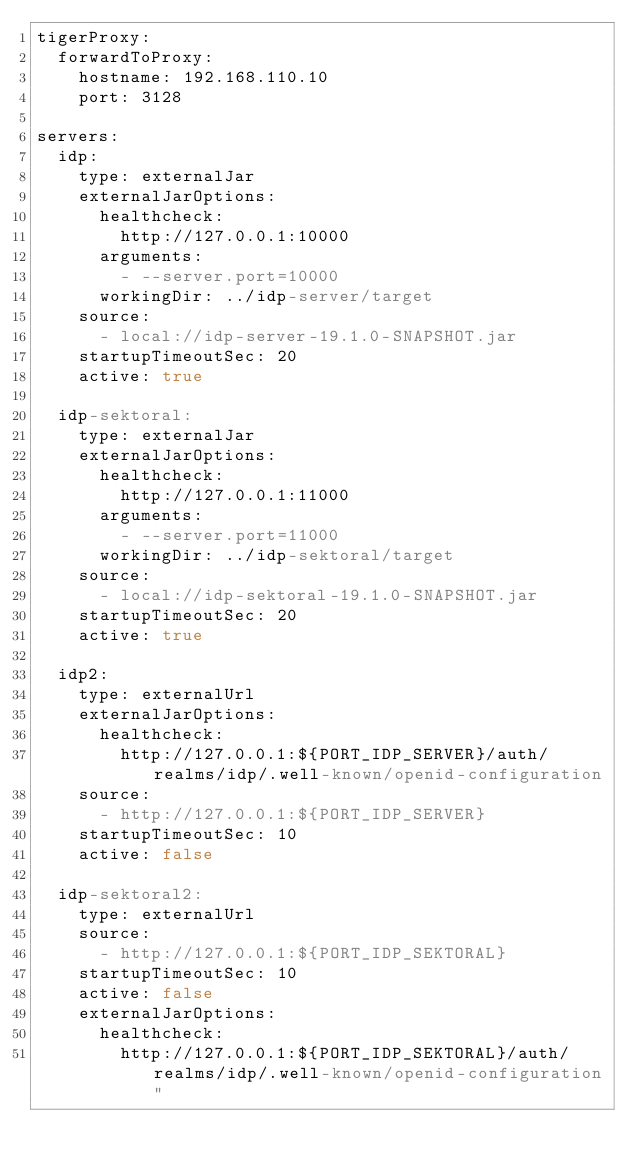Convert code to text. <code><loc_0><loc_0><loc_500><loc_500><_YAML_>tigerProxy:
  forwardToProxy:
    hostname: 192.168.110.10
    port: 3128

servers:
  idp:
    type: externalJar
    externalJarOptions:
      healthcheck:
        http://127.0.0.1:10000
      arguments:
        - --server.port=10000
      workingDir: ../idp-server/target
    source:
      - local://idp-server-19.1.0-SNAPSHOT.jar
    startupTimeoutSec: 20
    active: true

  idp-sektoral:
    type: externalJar
    externalJarOptions:
      healthcheck:
        http://127.0.0.1:11000
      arguments:
        - --server.port=11000
      workingDir: ../idp-sektoral/target
    source:
      - local://idp-sektoral-19.1.0-SNAPSHOT.jar
    startupTimeoutSec: 20
    active: true

  idp2:
    type: externalUrl
    externalJarOptions:
      healthcheck:
        http://127.0.0.1:${PORT_IDP_SERVER}/auth/realms/idp/.well-known/openid-configuration
    source:
      - http://127.0.0.1:${PORT_IDP_SERVER}
    startupTimeoutSec: 10
    active: false

  idp-sektoral2:
    type: externalUrl
    source:
      - http://127.0.0.1:${PORT_IDP_SEKTORAL}
    startupTimeoutSec: 10
    active: false
    externalJarOptions:
      healthcheck:
        http://127.0.0.1:${PORT_IDP_SEKTORAL}/auth/realms/idp/.well-known/openid-configuration"
</code> 